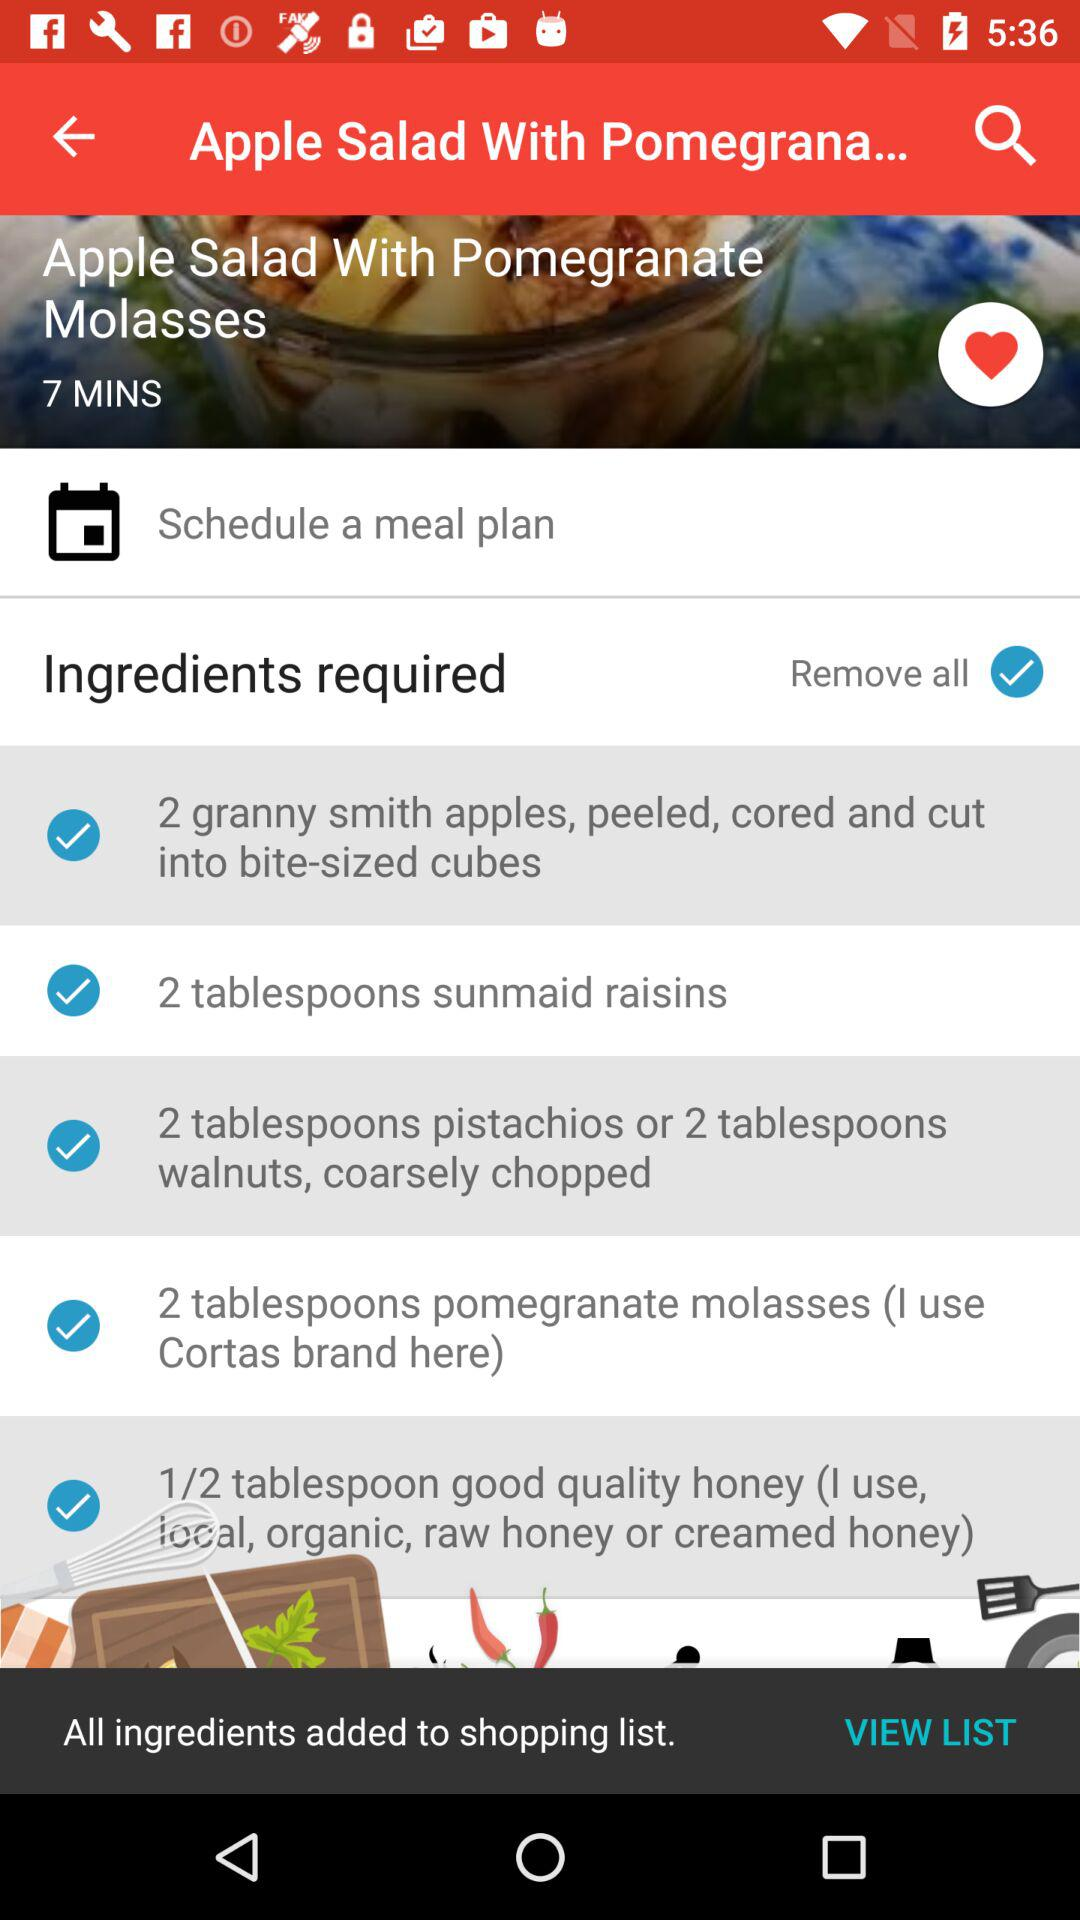How many tablespoons of "sunmaid raisins" are needed to prepare the dish? To prepare the dish, 2 tablespoons "sunmaid raisins" are needed. 